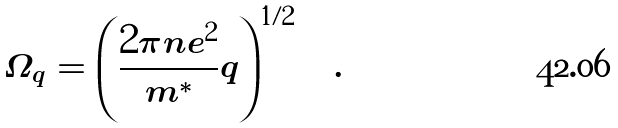Convert formula to latex. <formula><loc_0><loc_0><loc_500><loc_500>\Omega _ { q } = \left ( \frac { 2 \pi n e ^ { 2 } } { m ^ { * } } q \right ) ^ { 1 / 2 } \quad .</formula> 